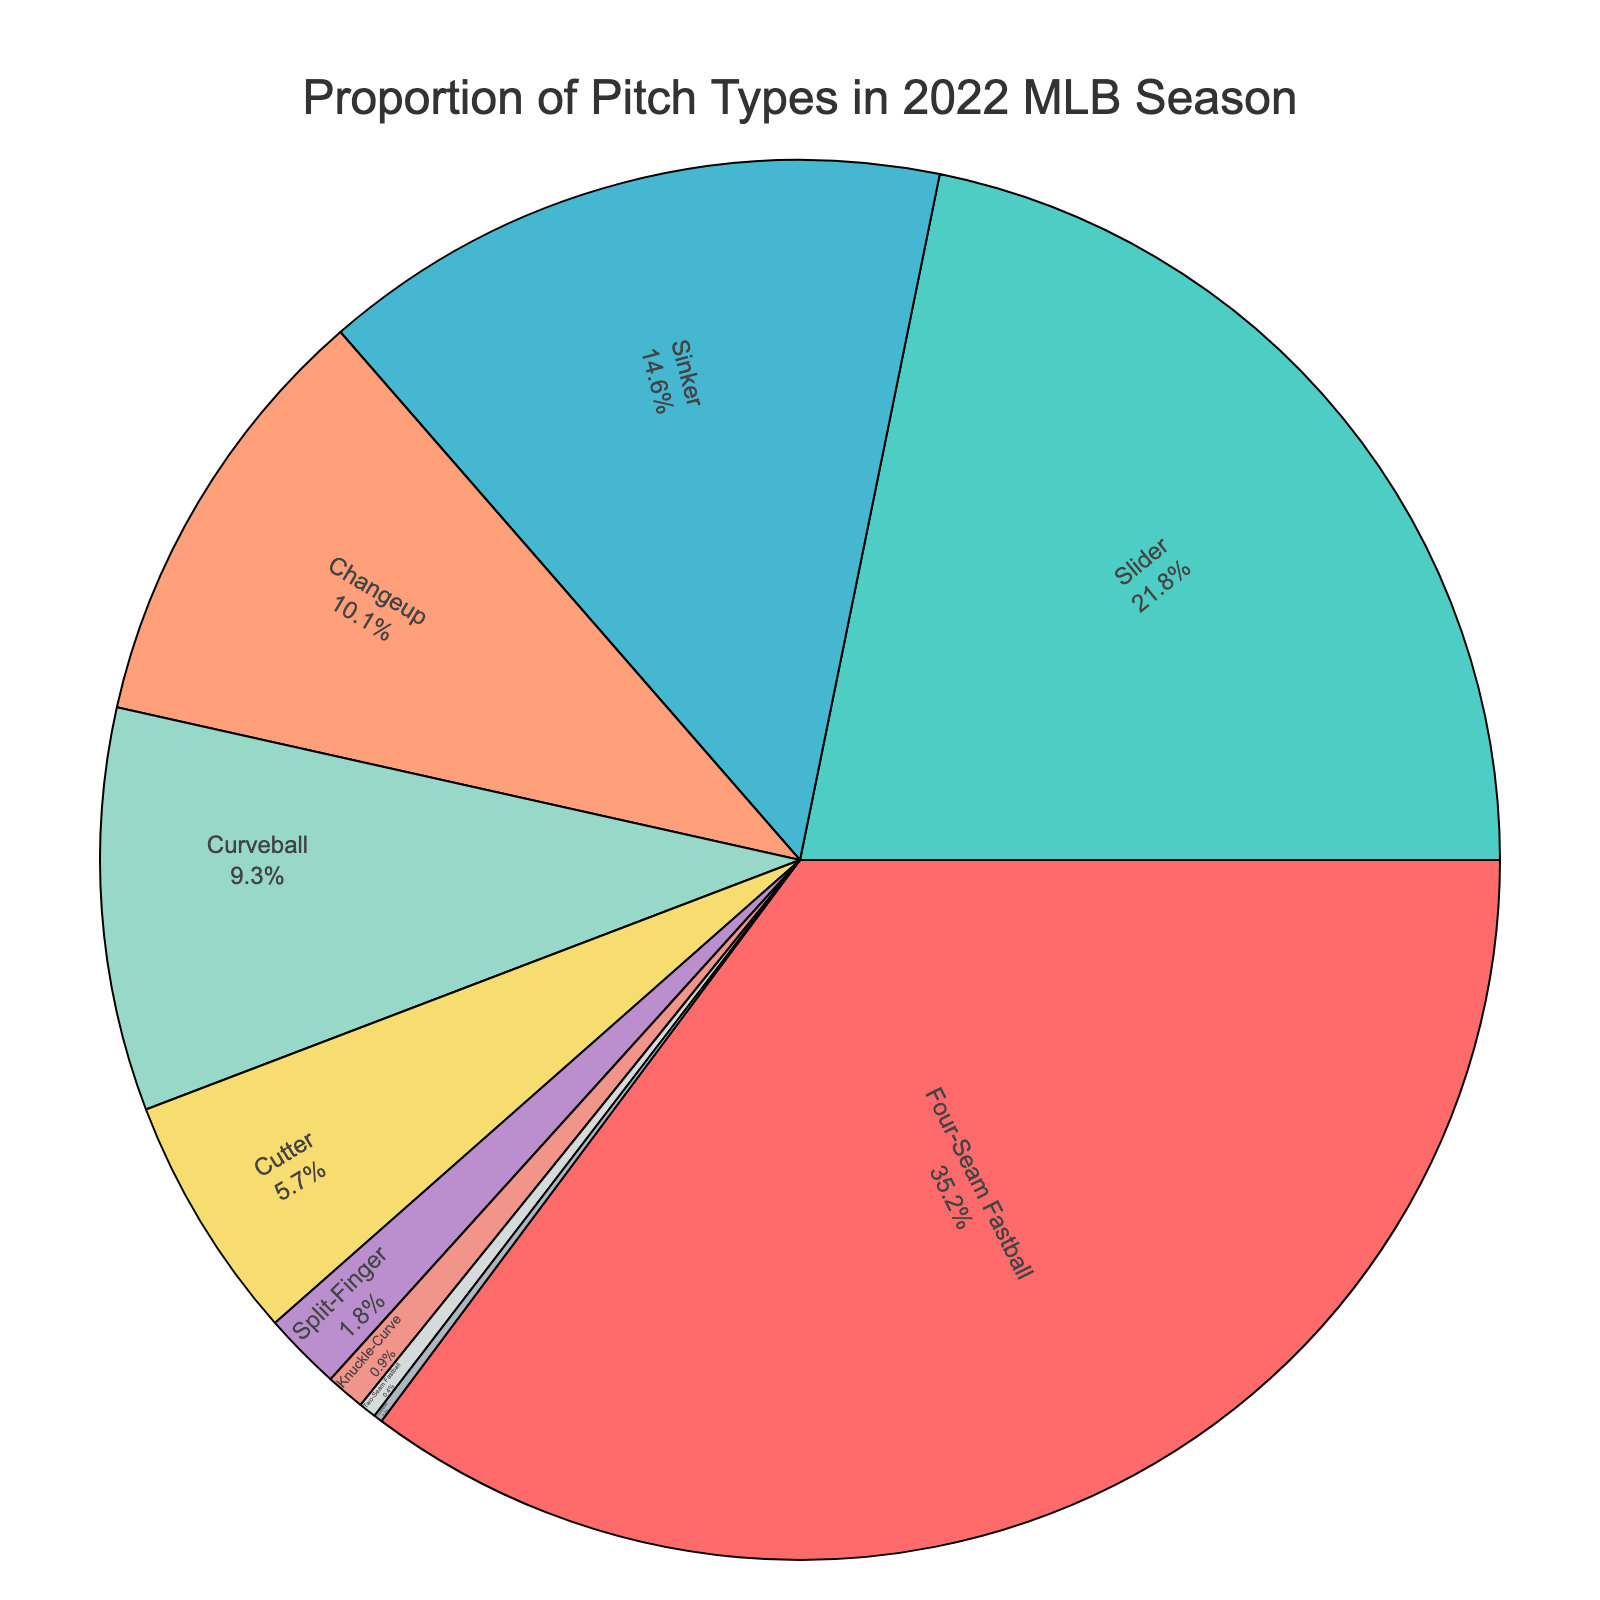What's the most common pitch type thrown in the 2022 MLB season? The chart shows the largest segment representing the pitch type with the highest percentage. The Four-Seam Fastball holds the largest portion of the pie.
Answer: Four-Seam Fastball Which pitch type is thrown less than the Knuckle-Curve but more than the Two-Seam Fastball? By examining the pie chart's segments and their percentages, the Split-Finger fits the criteria as its segment is larger than the Two-Seam Fastball but smaller than the Knuckle-Curve.
Answer: Split-Finger What is the total percentage of all fastball pitches thrown (Four-Seam Fastball, Sinker, Cutter, Two-Seam Fastball)? Add the percentages of the Four-Seam Fastball (35.2%), Sinker (14.6%), Cutter (5.7%), and Two-Seam Fastball (0.4%). The total is 35.2 + 14.6 + 5.7 + 0.4 = 55.9%.
Answer: 55.9% How does the percentage of sliders compare to curveballs? The chart shows that Slider has 21.8% while Curveball has 9.3%, which means Slider is more common.
Answer: Slider is more common What pitch type has the second smallest percentage and what is that percentage? Looking at the size of the segments from smallest to largest, the second smallest segment corresponds to the Knuckle-Curve at 0.9%.
Answer: Knuckle-Curve at 0.9% Is the combined percentage of Changeup and Cutter greater than that of Slider? Add the percentages of Changeup (10.1%) and Cutter (5.7%), which equals 15.8%. Compare this with Slider at 21.8%. 15.8% is less than 21.8%.
Answer: No Which color segment represents the most common pitch type? Observing the color of the largest segment associated with the Four-Seam Fastball, it's red.
Answer: Red What's the difference in percentage between the Sinker and Changeup pitch types? Subtract the percentage of Changeup (10.1%) from Sinker (14.6%) to get the difference, 14.6 - 10.1 = 4.5%.
Answer: 4.5% Do the total percentages of Curveball, Cutter, and Split-Finger add up to more than 15%? Add the percentages for Curveball (9.3%), Cutter (5.7%), and Split-Finger (1.8%), which equals 9.3 + 5.7 + 1.8 = 16.8%. Yes, 16.8% is more than 15%.
Answer: Yes Which pitch type appears as the smallest segment? The smallest segment corresponds to the Knuckleball, which has the least percentage (0.2%).
Answer: Knuckleball 